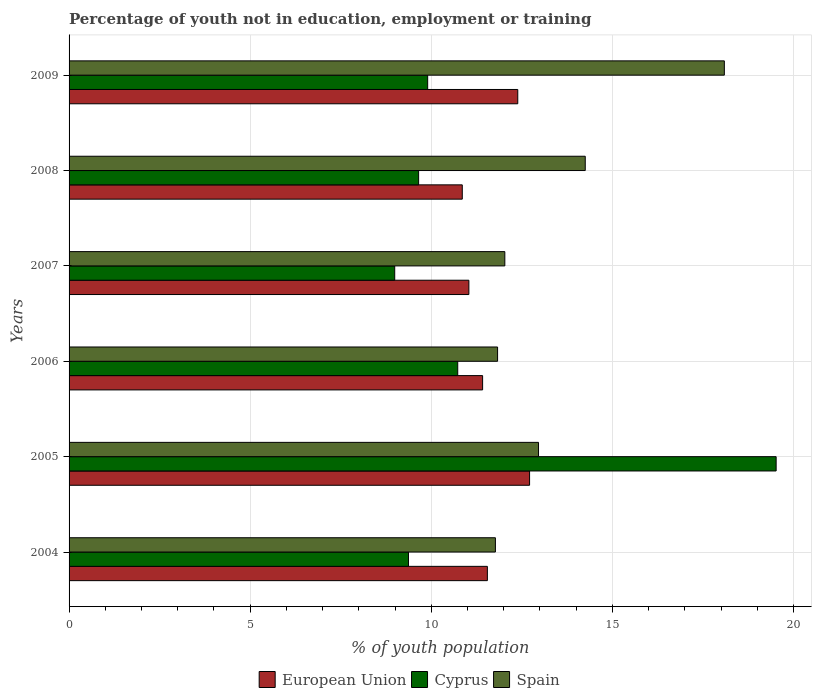How many different coloured bars are there?
Your answer should be very brief. 3. How many bars are there on the 4th tick from the top?
Make the answer very short. 3. How many bars are there on the 1st tick from the bottom?
Make the answer very short. 3. In how many cases, is the number of bars for a given year not equal to the number of legend labels?
Ensure brevity in your answer.  0. What is the percentage of unemployed youth population in in Cyprus in 2004?
Offer a terse response. 9.37. Across all years, what is the maximum percentage of unemployed youth population in in Spain?
Provide a succinct answer. 18.09. Across all years, what is the minimum percentage of unemployed youth population in in Cyprus?
Give a very brief answer. 8.99. What is the total percentage of unemployed youth population in in Cyprus in the graph?
Provide a succinct answer. 68.16. What is the difference between the percentage of unemployed youth population in in European Union in 2004 and the percentage of unemployed youth population in in Cyprus in 2005?
Your response must be concise. -7.97. What is the average percentage of unemployed youth population in in Spain per year?
Keep it short and to the point. 13.49. In the year 2009, what is the difference between the percentage of unemployed youth population in in European Union and percentage of unemployed youth population in in Spain?
Provide a short and direct response. -5.7. What is the ratio of the percentage of unemployed youth population in in European Union in 2004 to that in 2009?
Make the answer very short. 0.93. Is the percentage of unemployed youth population in in Spain in 2004 less than that in 2009?
Ensure brevity in your answer.  Yes. What is the difference between the highest and the second highest percentage of unemployed youth population in in European Union?
Provide a succinct answer. 0.33. What is the difference between the highest and the lowest percentage of unemployed youth population in in Cyprus?
Your answer should be very brief. 10.53. In how many years, is the percentage of unemployed youth population in in Cyprus greater than the average percentage of unemployed youth population in in Cyprus taken over all years?
Provide a succinct answer. 1. Is the sum of the percentage of unemployed youth population in in European Union in 2007 and 2008 greater than the maximum percentage of unemployed youth population in in Spain across all years?
Offer a very short reply. Yes. What does the 2nd bar from the top in 2005 represents?
Provide a succinct answer. Cyprus. What does the 1st bar from the bottom in 2009 represents?
Keep it short and to the point. European Union. Are all the bars in the graph horizontal?
Keep it short and to the point. Yes. How many years are there in the graph?
Give a very brief answer. 6. Where does the legend appear in the graph?
Make the answer very short. Bottom center. What is the title of the graph?
Offer a terse response. Percentage of youth not in education, employment or training. What is the label or title of the X-axis?
Ensure brevity in your answer.  % of youth population. What is the % of youth population of European Union in 2004?
Give a very brief answer. 11.55. What is the % of youth population in Cyprus in 2004?
Offer a very short reply. 9.37. What is the % of youth population in Spain in 2004?
Ensure brevity in your answer.  11.77. What is the % of youth population in European Union in 2005?
Make the answer very short. 12.71. What is the % of youth population in Cyprus in 2005?
Ensure brevity in your answer.  19.52. What is the % of youth population in Spain in 2005?
Keep it short and to the point. 12.96. What is the % of youth population in European Union in 2006?
Give a very brief answer. 11.42. What is the % of youth population of Cyprus in 2006?
Ensure brevity in your answer.  10.73. What is the % of youth population of Spain in 2006?
Ensure brevity in your answer.  11.83. What is the % of youth population of European Union in 2007?
Your response must be concise. 11.04. What is the % of youth population in Cyprus in 2007?
Offer a terse response. 8.99. What is the % of youth population in Spain in 2007?
Ensure brevity in your answer.  12.03. What is the % of youth population in European Union in 2008?
Keep it short and to the point. 10.86. What is the % of youth population in Cyprus in 2008?
Provide a succinct answer. 9.65. What is the % of youth population in Spain in 2008?
Your response must be concise. 14.25. What is the % of youth population of European Union in 2009?
Your response must be concise. 12.39. What is the % of youth population of Cyprus in 2009?
Provide a short and direct response. 9.9. What is the % of youth population of Spain in 2009?
Provide a succinct answer. 18.09. Across all years, what is the maximum % of youth population of European Union?
Keep it short and to the point. 12.71. Across all years, what is the maximum % of youth population in Cyprus?
Provide a succinct answer. 19.52. Across all years, what is the maximum % of youth population of Spain?
Give a very brief answer. 18.09. Across all years, what is the minimum % of youth population in European Union?
Your answer should be compact. 10.86. Across all years, what is the minimum % of youth population of Cyprus?
Offer a terse response. 8.99. Across all years, what is the minimum % of youth population of Spain?
Offer a terse response. 11.77. What is the total % of youth population in European Union in the graph?
Keep it short and to the point. 69.96. What is the total % of youth population of Cyprus in the graph?
Your answer should be very brief. 68.16. What is the total % of youth population in Spain in the graph?
Your answer should be compact. 80.93. What is the difference between the % of youth population in European Union in 2004 and that in 2005?
Your response must be concise. -1.17. What is the difference between the % of youth population of Cyprus in 2004 and that in 2005?
Your response must be concise. -10.15. What is the difference between the % of youth population of Spain in 2004 and that in 2005?
Provide a succinct answer. -1.19. What is the difference between the % of youth population of European Union in 2004 and that in 2006?
Provide a short and direct response. 0.13. What is the difference between the % of youth population of Cyprus in 2004 and that in 2006?
Offer a terse response. -1.36. What is the difference between the % of youth population of Spain in 2004 and that in 2006?
Ensure brevity in your answer.  -0.06. What is the difference between the % of youth population of European Union in 2004 and that in 2007?
Give a very brief answer. 0.51. What is the difference between the % of youth population in Cyprus in 2004 and that in 2007?
Give a very brief answer. 0.38. What is the difference between the % of youth population of Spain in 2004 and that in 2007?
Your answer should be compact. -0.26. What is the difference between the % of youth population of European Union in 2004 and that in 2008?
Make the answer very short. 0.69. What is the difference between the % of youth population in Cyprus in 2004 and that in 2008?
Ensure brevity in your answer.  -0.28. What is the difference between the % of youth population in Spain in 2004 and that in 2008?
Offer a terse response. -2.48. What is the difference between the % of youth population in European Union in 2004 and that in 2009?
Provide a short and direct response. -0.84. What is the difference between the % of youth population of Cyprus in 2004 and that in 2009?
Offer a terse response. -0.53. What is the difference between the % of youth population in Spain in 2004 and that in 2009?
Provide a short and direct response. -6.32. What is the difference between the % of youth population of European Union in 2005 and that in 2006?
Offer a very short reply. 1.3. What is the difference between the % of youth population in Cyprus in 2005 and that in 2006?
Offer a very short reply. 8.79. What is the difference between the % of youth population of Spain in 2005 and that in 2006?
Offer a terse response. 1.13. What is the difference between the % of youth population of European Union in 2005 and that in 2007?
Your response must be concise. 1.68. What is the difference between the % of youth population of Cyprus in 2005 and that in 2007?
Ensure brevity in your answer.  10.53. What is the difference between the % of youth population of Spain in 2005 and that in 2007?
Offer a terse response. 0.93. What is the difference between the % of youth population of European Union in 2005 and that in 2008?
Keep it short and to the point. 1.86. What is the difference between the % of youth population in Cyprus in 2005 and that in 2008?
Provide a succinct answer. 9.87. What is the difference between the % of youth population in Spain in 2005 and that in 2008?
Keep it short and to the point. -1.29. What is the difference between the % of youth population in European Union in 2005 and that in 2009?
Offer a very short reply. 0.33. What is the difference between the % of youth population in Cyprus in 2005 and that in 2009?
Offer a terse response. 9.62. What is the difference between the % of youth population of Spain in 2005 and that in 2009?
Your answer should be very brief. -5.13. What is the difference between the % of youth population in European Union in 2006 and that in 2007?
Your answer should be compact. 0.38. What is the difference between the % of youth population in Cyprus in 2006 and that in 2007?
Make the answer very short. 1.74. What is the difference between the % of youth population of Spain in 2006 and that in 2007?
Your answer should be compact. -0.2. What is the difference between the % of youth population in European Union in 2006 and that in 2008?
Make the answer very short. 0.56. What is the difference between the % of youth population of Spain in 2006 and that in 2008?
Provide a succinct answer. -2.42. What is the difference between the % of youth population in European Union in 2006 and that in 2009?
Your answer should be compact. -0.97. What is the difference between the % of youth population in Cyprus in 2006 and that in 2009?
Keep it short and to the point. 0.83. What is the difference between the % of youth population in Spain in 2006 and that in 2009?
Offer a very short reply. -6.26. What is the difference between the % of youth population in European Union in 2007 and that in 2008?
Your answer should be very brief. 0.18. What is the difference between the % of youth population in Cyprus in 2007 and that in 2008?
Keep it short and to the point. -0.66. What is the difference between the % of youth population of Spain in 2007 and that in 2008?
Your response must be concise. -2.22. What is the difference between the % of youth population in European Union in 2007 and that in 2009?
Ensure brevity in your answer.  -1.35. What is the difference between the % of youth population in Cyprus in 2007 and that in 2009?
Ensure brevity in your answer.  -0.91. What is the difference between the % of youth population of Spain in 2007 and that in 2009?
Offer a terse response. -6.06. What is the difference between the % of youth population of European Union in 2008 and that in 2009?
Offer a terse response. -1.53. What is the difference between the % of youth population of Spain in 2008 and that in 2009?
Keep it short and to the point. -3.84. What is the difference between the % of youth population of European Union in 2004 and the % of youth population of Cyprus in 2005?
Provide a short and direct response. -7.97. What is the difference between the % of youth population in European Union in 2004 and the % of youth population in Spain in 2005?
Make the answer very short. -1.41. What is the difference between the % of youth population in Cyprus in 2004 and the % of youth population in Spain in 2005?
Give a very brief answer. -3.59. What is the difference between the % of youth population of European Union in 2004 and the % of youth population of Cyprus in 2006?
Make the answer very short. 0.82. What is the difference between the % of youth population of European Union in 2004 and the % of youth population of Spain in 2006?
Offer a terse response. -0.28. What is the difference between the % of youth population in Cyprus in 2004 and the % of youth population in Spain in 2006?
Keep it short and to the point. -2.46. What is the difference between the % of youth population of European Union in 2004 and the % of youth population of Cyprus in 2007?
Offer a very short reply. 2.56. What is the difference between the % of youth population in European Union in 2004 and the % of youth population in Spain in 2007?
Your answer should be very brief. -0.48. What is the difference between the % of youth population in Cyprus in 2004 and the % of youth population in Spain in 2007?
Offer a terse response. -2.66. What is the difference between the % of youth population in European Union in 2004 and the % of youth population in Cyprus in 2008?
Your answer should be very brief. 1.9. What is the difference between the % of youth population of European Union in 2004 and the % of youth population of Spain in 2008?
Provide a succinct answer. -2.7. What is the difference between the % of youth population in Cyprus in 2004 and the % of youth population in Spain in 2008?
Your answer should be very brief. -4.88. What is the difference between the % of youth population in European Union in 2004 and the % of youth population in Cyprus in 2009?
Give a very brief answer. 1.65. What is the difference between the % of youth population of European Union in 2004 and the % of youth population of Spain in 2009?
Your answer should be compact. -6.54. What is the difference between the % of youth population in Cyprus in 2004 and the % of youth population in Spain in 2009?
Your answer should be very brief. -8.72. What is the difference between the % of youth population in European Union in 2005 and the % of youth population in Cyprus in 2006?
Your response must be concise. 1.98. What is the difference between the % of youth population in European Union in 2005 and the % of youth population in Spain in 2006?
Make the answer very short. 0.88. What is the difference between the % of youth population in Cyprus in 2005 and the % of youth population in Spain in 2006?
Provide a succinct answer. 7.69. What is the difference between the % of youth population in European Union in 2005 and the % of youth population in Cyprus in 2007?
Offer a terse response. 3.72. What is the difference between the % of youth population in European Union in 2005 and the % of youth population in Spain in 2007?
Your response must be concise. 0.68. What is the difference between the % of youth population of Cyprus in 2005 and the % of youth population of Spain in 2007?
Give a very brief answer. 7.49. What is the difference between the % of youth population of European Union in 2005 and the % of youth population of Cyprus in 2008?
Provide a short and direct response. 3.06. What is the difference between the % of youth population of European Union in 2005 and the % of youth population of Spain in 2008?
Offer a terse response. -1.54. What is the difference between the % of youth population in Cyprus in 2005 and the % of youth population in Spain in 2008?
Offer a terse response. 5.27. What is the difference between the % of youth population of European Union in 2005 and the % of youth population of Cyprus in 2009?
Keep it short and to the point. 2.81. What is the difference between the % of youth population in European Union in 2005 and the % of youth population in Spain in 2009?
Offer a terse response. -5.38. What is the difference between the % of youth population in Cyprus in 2005 and the % of youth population in Spain in 2009?
Ensure brevity in your answer.  1.43. What is the difference between the % of youth population in European Union in 2006 and the % of youth population in Cyprus in 2007?
Offer a terse response. 2.43. What is the difference between the % of youth population of European Union in 2006 and the % of youth population of Spain in 2007?
Make the answer very short. -0.61. What is the difference between the % of youth population in Cyprus in 2006 and the % of youth population in Spain in 2007?
Provide a short and direct response. -1.3. What is the difference between the % of youth population in European Union in 2006 and the % of youth population in Cyprus in 2008?
Offer a terse response. 1.77. What is the difference between the % of youth population of European Union in 2006 and the % of youth population of Spain in 2008?
Your answer should be very brief. -2.83. What is the difference between the % of youth population in Cyprus in 2006 and the % of youth population in Spain in 2008?
Provide a short and direct response. -3.52. What is the difference between the % of youth population of European Union in 2006 and the % of youth population of Cyprus in 2009?
Provide a short and direct response. 1.52. What is the difference between the % of youth population of European Union in 2006 and the % of youth population of Spain in 2009?
Offer a terse response. -6.67. What is the difference between the % of youth population of Cyprus in 2006 and the % of youth population of Spain in 2009?
Provide a succinct answer. -7.36. What is the difference between the % of youth population of European Union in 2007 and the % of youth population of Cyprus in 2008?
Provide a succinct answer. 1.39. What is the difference between the % of youth population in European Union in 2007 and the % of youth population in Spain in 2008?
Your answer should be compact. -3.21. What is the difference between the % of youth population of Cyprus in 2007 and the % of youth population of Spain in 2008?
Keep it short and to the point. -5.26. What is the difference between the % of youth population of European Union in 2007 and the % of youth population of Cyprus in 2009?
Make the answer very short. 1.14. What is the difference between the % of youth population of European Union in 2007 and the % of youth population of Spain in 2009?
Make the answer very short. -7.05. What is the difference between the % of youth population in Cyprus in 2007 and the % of youth population in Spain in 2009?
Ensure brevity in your answer.  -9.1. What is the difference between the % of youth population in European Union in 2008 and the % of youth population in Cyprus in 2009?
Your answer should be compact. 0.96. What is the difference between the % of youth population in European Union in 2008 and the % of youth population in Spain in 2009?
Make the answer very short. -7.23. What is the difference between the % of youth population of Cyprus in 2008 and the % of youth population of Spain in 2009?
Provide a short and direct response. -8.44. What is the average % of youth population of European Union per year?
Your response must be concise. 11.66. What is the average % of youth population in Cyprus per year?
Ensure brevity in your answer.  11.36. What is the average % of youth population in Spain per year?
Your answer should be very brief. 13.49. In the year 2004, what is the difference between the % of youth population of European Union and % of youth population of Cyprus?
Make the answer very short. 2.18. In the year 2004, what is the difference between the % of youth population in European Union and % of youth population in Spain?
Provide a succinct answer. -0.22. In the year 2004, what is the difference between the % of youth population in Cyprus and % of youth population in Spain?
Give a very brief answer. -2.4. In the year 2005, what is the difference between the % of youth population of European Union and % of youth population of Cyprus?
Provide a succinct answer. -6.81. In the year 2005, what is the difference between the % of youth population in European Union and % of youth population in Spain?
Provide a short and direct response. -0.25. In the year 2005, what is the difference between the % of youth population of Cyprus and % of youth population of Spain?
Offer a very short reply. 6.56. In the year 2006, what is the difference between the % of youth population of European Union and % of youth population of Cyprus?
Make the answer very short. 0.69. In the year 2006, what is the difference between the % of youth population in European Union and % of youth population in Spain?
Ensure brevity in your answer.  -0.41. In the year 2007, what is the difference between the % of youth population in European Union and % of youth population in Cyprus?
Offer a terse response. 2.05. In the year 2007, what is the difference between the % of youth population in European Union and % of youth population in Spain?
Provide a succinct answer. -0.99. In the year 2007, what is the difference between the % of youth population in Cyprus and % of youth population in Spain?
Your answer should be very brief. -3.04. In the year 2008, what is the difference between the % of youth population of European Union and % of youth population of Cyprus?
Provide a short and direct response. 1.21. In the year 2008, what is the difference between the % of youth population of European Union and % of youth population of Spain?
Provide a succinct answer. -3.39. In the year 2008, what is the difference between the % of youth population in Cyprus and % of youth population in Spain?
Provide a succinct answer. -4.6. In the year 2009, what is the difference between the % of youth population of European Union and % of youth population of Cyprus?
Make the answer very short. 2.49. In the year 2009, what is the difference between the % of youth population in European Union and % of youth population in Spain?
Ensure brevity in your answer.  -5.7. In the year 2009, what is the difference between the % of youth population of Cyprus and % of youth population of Spain?
Your answer should be very brief. -8.19. What is the ratio of the % of youth population of European Union in 2004 to that in 2005?
Provide a succinct answer. 0.91. What is the ratio of the % of youth population in Cyprus in 2004 to that in 2005?
Offer a very short reply. 0.48. What is the ratio of the % of youth population of Spain in 2004 to that in 2005?
Your answer should be very brief. 0.91. What is the ratio of the % of youth population in European Union in 2004 to that in 2006?
Provide a succinct answer. 1.01. What is the ratio of the % of youth population in Cyprus in 2004 to that in 2006?
Your answer should be compact. 0.87. What is the ratio of the % of youth population in European Union in 2004 to that in 2007?
Your response must be concise. 1.05. What is the ratio of the % of youth population in Cyprus in 2004 to that in 2007?
Keep it short and to the point. 1.04. What is the ratio of the % of youth population of Spain in 2004 to that in 2007?
Your response must be concise. 0.98. What is the ratio of the % of youth population of European Union in 2004 to that in 2008?
Offer a very short reply. 1.06. What is the ratio of the % of youth population of Spain in 2004 to that in 2008?
Your response must be concise. 0.83. What is the ratio of the % of youth population of European Union in 2004 to that in 2009?
Provide a succinct answer. 0.93. What is the ratio of the % of youth population of Cyprus in 2004 to that in 2009?
Make the answer very short. 0.95. What is the ratio of the % of youth population in Spain in 2004 to that in 2009?
Your answer should be very brief. 0.65. What is the ratio of the % of youth population in European Union in 2005 to that in 2006?
Offer a very short reply. 1.11. What is the ratio of the % of youth population in Cyprus in 2005 to that in 2006?
Ensure brevity in your answer.  1.82. What is the ratio of the % of youth population of Spain in 2005 to that in 2006?
Offer a terse response. 1.1. What is the ratio of the % of youth population of European Union in 2005 to that in 2007?
Keep it short and to the point. 1.15. What is the ratio of the % of youth population in Cyprus in 2005 to that in 2007?
Keep it short and to the point. 2.17. What is the ratio of the % of youth population in Spain in 2005 to that in 2007?
Make the answer very short. 1.08. What is the ratio of the % of youth population in European Union in 2005 to that in 2008?
Provide a succinct answer. 1.17. What is the ratio of the % of youth population in Cyprus in 2005 to that in 2008?
Provide a succinct answer. 2.02. What is the ratio of the % of youth population in Spain in 2005 to that in 2008?
Ensure brevity in your answer.  0.91. What is the ratio of the % of youth population in European Union in 2005 to that in 2009?
Your answer should be very brief. 1.03. What is the ratio of the % of youth population in Cyprus in 2005 to that in 2009?
Your response must be concise. 1.97. What is the ratio of the % of youth population of Spain in 2005 to that in 2009?
Offer a very short reply. 0.72. What is the ratio of the % of youth population of European Union in 2006 to that in 2007?
Ensure brevity in your answer.  1.03. What is the ratio of the % of youth population of Cyprus in 2006 to that in 2007?
Your response must be concise. 1.19. What is the ratio of the % of youth population of Spain in 2006 to that in 2007?
Give a very brief answer. 0.98. What is the ratio of the % of youth population of European Union in 2006 to that in 2008?
Provide a short and direct response. 1.05. What is the ratio of the % of youth population of Cyprus in 2006 to that in 2008?
Offer a very short reply. 1.11. What is the ratio of the % of youth population in Spain in 2006 to that in 2008?
Keep it short and to the point. 0.83. What is the ratio of the % of youth population in European Union in 2006 to that in 2009?
Give a very brief answer. 0.92. What is the ratio of the % of youth population of Cyprus in 2006 to that in 2009?
Ensure brevity in your answer.  1.08. What is the ratio of the % of youth population of Spain in 2006 to that in 2009?
Provide a short and direct response. 0.65. What is the ratio of the % of youth population in European Union in 2007 to that in 2008?
Offer a very short reply. 1.02. What is the ratio of the % of youth population of Cyprus in 2007 to that in 2008?
Ensure brevity in your answer.  0.93. What is the ratio of the % of youth population of Spain in 2007 to that in 2008?
Offer a terse response. 0.84. What is the ratio of the % of youth population of European Union in 2007 to that in 2009?
Provide a short and direct response. 0.89. What is the ratio of the % of youth population in Cyprus in 2007 to that in 2009?
Offer a terse response. 0.91. What is the ratio of the % of youth population of Spain in 2007 to that in 2009?
Provide a succinct answer. 0.67. What is the ratio of the % of youth population in European Union in 2008 to that in 2009?
Offer a very short reply. 0.88. What is the ratio of the % of youth population of Cyprus in 2008 to that in 2009?
Give a very brief answer. 0.97. What is the ratio of the % of youth population in Spain in 2008 to that in 2009?
Provide a succinct answer. 0.79. What is the difference between the highest and the second highest % of youth population of European Union?
Your answer should be compact. 0.33. What is the difference between the highest and the second highest % of youth population of Cyprus?
Provide a succinct answer. 8.79. What is the difference between the highest and the second highest % of youth population of Spain?
Keep it short and to the point. 3.84. What is the difference between the highest and the lowest % of youth population of European Union?
Keep it short and to the point. 1.86. What is the difference between the highest and the lowest % of youth population of Cyprus?
Ensure brevity in your answer.  10.53. What is the difference between the highest and the lowest % of youth population in Spain?
Give a very brief answer. 6.32. 